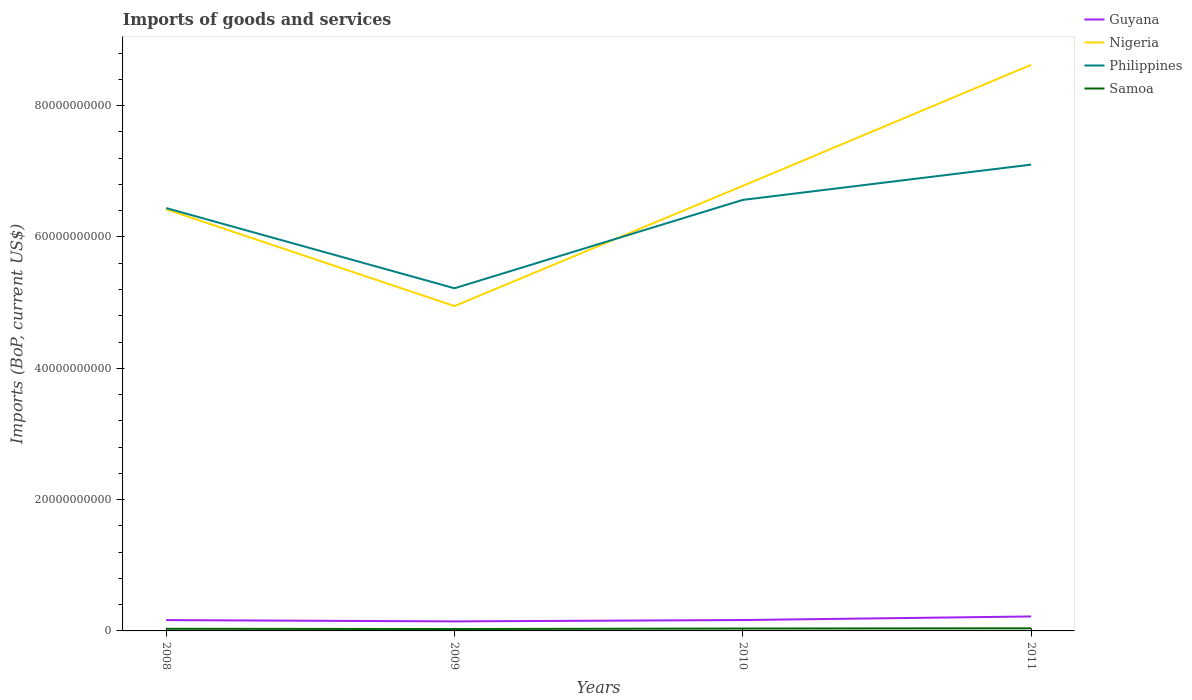Does the line corresponding to Guyana intersect with the line corresponding to Nigeria?
Provide a short and direct response. No. Across all years, what is the maximum amount spent on imports in Philippines?
Offer a terse response. 5.22e+1. What is the total amount spent on imports in Guyana in the graph?
Give a very brief answer. -5.47e+08. What is the difference between the highest and the second highest amount spent on imports in Samoa?
Keep it short and to the point. 1.09e+08. Are the values on the major ticks of Y-axis written in scientific E-notation?
Provide a succinct answer. No. Does the graph contain grids?
Give a very brief answer. No. Where does the legend appear in the graph?
Your response must be concise. Top right. What is the title of the graph?
Provide a succinct answer. Imports of goods and services. Does "Norway" appear as one of the legend labels in the graph?
Provide a short and direct response. No. What is the label or title of the Y-axis?
Offer a terse response. Imports (BoP, current US$). What is the Imports (BoP, current US$) in Guyana in 2008?
Provide a short and direct response. 1.65e+09. What is the Imports (BoP, current US$) of Nigeria in 2008?
Provide a short and direct response. 6.42e+1. What is the Imports (BoP, current US$) of Philippines in 2008?
Ensure brevity in your answer.  6.44e+1. What is the Imports (BoP, current US$) of Samoa in 2008?
Your answer should be very brief. 3.22e+08. What is the Imports (BoP, current US$) of Guyana in 2009?
Ensure brevity in your answer.  1.45e+09. What is the Imports (BoP, current US$) of Nigeria in 2009?
Keep it short and to the point. 4.95e+1. What is the Imports (BoP, current US$) of Philippines in 2009?
Your answer should be very brief. 5.22e+1. What is the Imports (BoP, current US$) in Samoa in 2009?
Ensure brevity in your answer.  2.87e+08. What is the Imports (BoP, current US$) in Guyana in 2010?
Provide a short and direct response. 1.66e+09. What is the Imports (BoP, current US$) in Nigeria in 2010?
Provide a succinct answer. 6.78e+1. What is the Imports (BoP, current US$) of Philippines in 2010?
Give a very brief answer. 6.56e+1. What is the Imports (BoP, current US$) of Samoa in 2010?
Make the answer very short. 3.62e+08. What is the Imports (BoP, current US$) of Guyana in 2011?
Provide a short and direct response. 2.20e+09. What is the Imports (BoP, current US$) in Nigeria in 2011?
Your response must be concise. 8.62e+1. What is the Imports (BoP, current US$) of Philippines in 2011?
Provide a short and direct response. 7.10e+1. What is the Imports (BoP, current US$) in Samoa in 2011?
Offer a very short reply. 3.97e+08. Across all years, what is the maximum Imports (BoP, current US$) of Guyana?
Your response must be concise. 2.20e+09. Across all years, what is the maximum Imports (BoP, current US$) in Nigeria?
Offer a very short reply. 8.62e+1. Across all years, what is the maximum Imports (BoP, current US$) in Philippines?
Your response must be concise. 7.10e+1. Across all years, what is the maximum Imports (BoP, current US$) of Samoa?
Ensure brevity in your answer.  3.97e+08. Across all years, what is the minimum Imports (BoP, current US$) in Guyana?
Your answer should be very brief. 1.45e+09. Across all years, what is the minimum Imports (BoP, current US$) in Nigeria?
Your answer should be very brief. 4.95e+1. Across all years, what is the minimum Imports (BoP, current US$) of Philippines?
Provide a short and direct response. 5.22e+1. Across all years, what is the minimum Imports (BoP, current US$) of Samoa?
Your answer should be very brief. 2.87e+08. What is the total Imports (BoP, current US$) in Guyana in the graph?
Keep it short and to the point. 6.96e+09. What is the total Imports (BoP, current US$) of Nigeria in the graph?
Keep it short and to the point. 2.68e+11. What is the total Imports (BoP, current US$) of Philippines in the graph?
Offer a very short reply. 2.53e+11. What is the total Imports (BoP, current US$) of Samoa in the graph?
Your response must be concise. 1.37e+09. What is the difference between the Imports (BoP, current US$) in Guyana in 2008 and that in 2009?
Your response must be concise. 1.97e+08. What is the difference between the Imports (BoP, current US$) of Nigeria in 2008 and that in 2009?
Ensure brevity in your answer.  1.47e+1. What is the difference between the Imports (BoP, current US$) of Philippines in 2008 and that in 2009?
Keep it short and to the point. 1.22e+1. What is the difference between the Imports (BoP, current US$) in Samoa in 2008 and that in 2009?
Provide a short and direct response. 3.50e+07. What is the difference between the Imports (BoP, current US$) of Guyana in 2008 and that in 2010?
Provide a short and direct response. -8.76e+06. What is the difference between the Imports (BoP, current US$) of Nigeria in 2008 and that in 2010?
Your answer should be very brief. -3.56e+09. What is the difference between the Imports (BoP, current US$) of Philippines in 2008 and that in 2010?
Offer a very short reply. -1.24e+09. What is the difference between the Imports (BoP, current US$) in Samoa in 2008 and that in 2010?
Give a very brief answer. -3.93e+07. What is the difference between the Imports (BoP, current US$) in Guyana in 2008 and that in 2011?
Your response must be concise. -5.55e+08. What is the difference between the Imports (BoP, current US$) in Nigeria in 2008 and that in 2011?
Your answer should be very brief. -2.20e+1. What is the difference between the Imports (BoP, current US$) of Philippines in 2008 and that in 2011?
Offer a terse response. -6.61e+09. What is the difference between the Imports (BoP, current US$) in Samoa in 2008 and that in 2011?
Offer a very short reply. -7.43e+07. What is the difference between the Imports (BoP, current US$) of Guyana in 2009 and that in 2010?
Provide a short and direct response. -2.06e+08. What is the difference between the Imports (BoP, current US$) in Nigeria in 2009 and that in 2010?
Your answer should be compact. -1.83e+1. What is the difference between the Imports (BoP, current US$) of Philippines in 2009 and that in 2010?
Your answer should be very brief. -1.35e+1. What is the difference between the Imports (BoP, current US$) in Samoa in 2009 and that in 2010?
Ensure brevity in your answer.  -7.43e+07. What is the difference between the Imports (BoP, current US$) of Guyana in 2009 and that in 2011?
Your answer should be compact. -7.52e+08. What is the difference between the Imports (BoP, current US$) of Nigeria in 2009 and that in 2011?
Your answer should be very brief. -3.68e+1. What is the difference between the Imports (BoP, current US$) in Philippines in 2009 and that in 2011?
Your response must be concise. -1.88e+1. What is the difference between the Imports (BoP, current US$) in Samoa in 2009 and that in 2011?
Keep it short and to the point. -1.09e+08. What is the difference between the Imports (BoP, current US$) in Guyana in 2010 and that in 2011?
Your answer should be compact. -5.47e+08. What is the difference between the Imports (BoP, current US$) in Nigeria in 2010 and that in 2011?
Your answer should be very brief. -1.84e+1. What is the difference between the Imports (BoP, current US$) in Philippines in 2010 and that in 2011?
Give a very brief answer. -5.37e+09. What is the difference between the Imports (BoP, current US$) of Samoa in 2010 and that in 2011?
Provide a succinct answer. -3.51e+07. What is the difference between the Imports (BoP, current US$) of Guyana in 2008 and the Imports (BoP, current US$) of Nigeria in 2009?
Provide a succinct answer. -4.78e+1. What is the difference between the Imports (BoP, current US$) in Guyana in 2008 and the Imports (BoP, current US$) in Philippines in 2009?
Your response must be concise. -5.05e+1. What is the difference between the Imports (BoP, current US$) in Guyana in 2008 and the Imports (BoP, current US$) in Samoa in 2009?
Give a very brief answer. 1.36e+09. What is the difference between the Imports (BoP, current US$) in Nigeria in 2008 and the Imports (BoP, current US$) in Philippines in 2009?
Your answer should be very brief. 1.20e+1. What is the difference between the Imports (BoP, current US$) of Nigeria in 2008 and the Imports (BoP, current US$) of Samoa in 2009?
Ensure brevity in your answer.  6.39e+1. What is the difference between the Imports (BoP, current US$) of Philippines in 2008 and the Imports (BoP, current US$) of Samoa in 2009?
Give a very brief answer. 6.41e+1. What is the difference between the Imports (BoP, current US$) of Guyana in 2008 and the Imports (BoP, current US$) of Nigeria in 2010?
Your answer should be compact. -6.61e+1. What is the difference between the Imports (BoP, current US$) of Guyana in 2008 and the Imports (BoP, current US$) of Philippines in 2010?
Your answer should be very brief. -6.40e+1. What is the difference between the Imports (BoP, current US$) in Guyana in 2008 and the Imports (BoP, current US$) in Samoa in 2010?
Offer a very short reply. 1.29e+09. What is the difference between the Imports (BoP, current US$) in Nigeria in 2008 and the Imports (BoP, current US$) in Philippines in 2010?
Ensure brevity in your answer.  -1.43e+09. What is the difference between the Imports (BoP, current US$) of Nigeria in 2008 and the Imports (BoP, current US$) of Samoa in 2010?
Give a very brief answer. 6.39e+1. What is the difference between the Imports (BoP, current US$) in Philippines in 2008 and the Imports (BoP, current US$) in Samoa in 2010?
Provide a short and direct response. 6.40e+1. What is the difference between the Imports (BoP, current US$) of Guyana in 2008 and the Imports (BoP, current US$) of Nigeria in 2011?
Provide a succinct answer. -8.46e+1. What is the difference between the Imports (BoP, current US$) in Guyana in 2008 and the Imports (BoP, current US$) in Philippines in 2011?
Provide a short and direct response. -6.94e+1. What is the difference between the Imports (BoP, current US$) in Guyana in 2008 and the Imports (BoP, current US$) in Samoa in 2011?
Your answer should be very brief. 1.25e+09. What is the difference between the Imports (BoP, current US$) in Nigeria in 2008 and the Imports (BoP, current US$) in Philippines in 2011?
Your response must be concise. -6.80e+09. What is the difference between the Imports (BoP, current US$) of Nigeria in 2008 and the Imports (BoP, current US$) of Samoa in 2011?
Keep it short and to the point. 6.38e+1. What is the difference between the Imports (BoP, current US$) of Philippines in 2008 and the Imports (BoP, current US$) of Samoa in 2011?
Ensure brevity in your answer.  6.40e+1. What is the difference between the Imports (BoP, current US$) of Guyana in 2009 and the Imports (BoP, current US$) of Nigeria in 2010?
Give a very brief answer. -6.63e+1. What is the difference between the Imports (BoP, current US$) of Guyana in 2009 and the Imports (BoP, current US$) of Philippines in 2010?
Provide a succinct answer. -6.42e+1. What is the difference between the Imports (BoP, current US$) of Guyana in 2009 and the Imports (BoP, current US$) of Samoa in 2010?
Give a very brief answer. 1.09e+09. What is the difference between the Imports (BoP, current US$) in Nigeria in 2009 and the Imports (BoP, current US$) in Philippines in 2010?
Make the answer very short. -1.62e+1. What is the difference between the Imports (BoP, current US$) in Nigeria in 2009 and the Imports (BoP, current US$) in Samoa in 2010?
Keep it short and to the point. 4.91e+1. What is the difference between the Imports (BoP, current US$) of Philippines in 2009 and the Imports (BoP, current US$) of Samoa in 2010?
Offer a very short reply. 5.18e+1. What is the difference between the Imports (BoP, current US$) in Guyana in 2009 and the Imports (BoP, current US$) in Nigeria in 2011?
Provide a succinct answer. -8.48e+1. What is the difference between the Imports (BoP, current US$) of Guyana in 2009 and the Imports (BoP, current US$) of Philippines in 2011?
Your answer should be compact. -6.96e+1. What is the difference between the Imports (BoP, current US$) in Guyana in 2009 and the Imports (BoP, current US$) in Samoa in 2011?
Make the answer very short. 1.06e+09. What is the difference between the Imports (BoP, current US$) in Nigeria in 2009 and the Imports (BoP, current US$) in Philippines in 2011?
Your answer should be very brief. -2.15e+1. What is the difference between the Imports (BoP, current US$) in Nigeria in 2009 and the Imports (BoP, current US$) in Samoa in 2011?
Your answer should be very brief. 4.91e+1. What is the difference between the Imports (BoP, current US$) of Philippines in 2009 and the Imports (BoP, current US$) of Samoa in 2011?
Provide a succinct answer. 5.18e+1. What is the difference between the Imports (BoP, current US$) in Guyana in 2010 and the Imports (BoP, current US$) in Nigeria in 2011?
Your answer should be very brief. -8.46e+1. What is the difference between the Imports (BoP, current US$) in Guyana in 2010 and the Imports (BoP, current US$) in Philippines in 2011?
Provide a succinct answer. -6.94e+1. What is the difference between the Imports (BoP, current US$) in Guyana in 2010 and the Imports (BoP, current US$) in Samoa in 2011?
Keep it short and to the point. 1.26e+09. What is the difference between the Imports (BoP, current US$) in Nigeria in 2010 and the Imports (BoP, current US$) in Philippines in 2011?
Offer a terse response. -3.24e+09. What is the difference between the Imports (BoP, current US$) in Nigeria in 2010 and the Imports (BoP, current US$) in Samoa in 2011?
Offer a terse response. 6.74e+1. What is the difference between the Imports (BoP, current US$) in Philippines in 2010 and the Imports (BoP, current US$) in Samoa in 2011?
Ensure brevity in your answer.  6.53e+1. What is the average Imports (BoP, current US$) in Guyana per year?
Provide a short and direct response. 1.74e+09. What is the average Imports (BoP, current US$) of Nigeria per year?
Your response must be concise. 6.69e+1. What is the average Imports (BoP, current US$) of Philippines per year?
Keep it short and to the point. 6.33e+1. What is the average Imports (BoP, current US$) of Samoa per year?
Your answer should be very brief. 3.42e+08. In the year 2008, what is the difference between the Imports (BoP, current US$) of Guyana and Imports (BoP, current US$) of Nigeria?
Keep it short and to the point. -6.26e+1. In the year 2008, what is the difference between the Imports (BoP, current US$) in Guyana and Imports (BoP, current US$) in Philippines?
Provide a succinct answer. -6.28e+1. In the year 2008, what is the difference between the Imports (BoP, current US$) of Guyana and Imports (BoP, current US$) of Samoa?
Provide a succinct answer. 1.33e+09. In the year 2008, what is the difference between the Imports (BoP, current US$) of Nigeria and Imports (BoP, current US$) of Philippines?
Your response must be concise. -1.88e+08. In the year 2008, what is the difference between the Imports (BoP, current US$) in Nigeria and Imports (BoP, current US$) in Samoa?
Provide a short and direct response. 6.39e+1. In the year 2008, what is the difference between the Imports (BoP, current US$) in Philippines and Imports (BoP, current US$) in Samoa?
Your answer should be compact. 6.41e+1. In the year 2009, what is the difference between the Imports (BoP, current US$) of Guyana and Imports (BoP, current US$) of Nigeria?
Ensure brevity in your answer.  -4.80e+1. In the year 2009, what is the difference between the Imports (BoP, current US$) of Guyana and Imports (BoP, current US$) of Philippines?
Give a very brief answer. -5.07e+1. In the year 2009, what is the difference between the Imports (BoP, current US$) in Guyana and Imports (BoP, current US$) in Samoa?
Offer a very short reply. 1.16e+09. In the year 2009, what is the difference between the Imports (BoP, current US$) in Nigeria and Imports (BoP, current US$) in Philippines?
Keep it short and to the point. -2.71e+09. In the year 2009, what is the difference between the Imports (BoP, current US$) of Nigeria and Imports (BoP, current US$) of Samoa?
Offer a terse response. 4.92e+1. In the year 2009, what is the difference between the Imports (BoP, current US$) in Philippines and Imports (BoP, current US$) in Samoa?
Keep it short and to the point. 5.19e+1. In the year 2010, what is the difference between the Imports (BoP, current US$) of Guyana and Imports (BoP, current US$) of Nigeria?
Provide a short and direct response. -6.61e+1. In the year 2010, what is the difference between the Imports (BoP, current US$) in Guyana and Imports (BoP, current US$) in Philippines?
Keep it short and to the point. -6.40e+1. In the year 2010, what is the difference between the Imports (BoP, current US$) in Guyana and Imports (BoP, current US$) in Samoa?
Ensure brevity in your answer.  1.30e+09. In the year 2010, what is the difference between the Imports (BoP, current US$) of Nigeria and Imports (BoP, current US$) of Philippines?
Ensure brevity in your answer.  2.14e+09. In the year 2010, what is the difference between the Imports (BoP, current US$) in Nigeria and Imports (BoP, current US$) in Samoa?
Your answer should be very brief. 6.74e+1. In the year 2010, what is the difference between the Imports (BoP, current US$) of Philippines and Imports (BoP, current US$) of Samoa?
Offer a terse response. 6.53e+1. In the year 2011, what is the difference between the Imports (BoP, current US$) in Guyana and Imports (BoP, current US$) in Nigeria?
Offer a terse response. -8.40e+1. In the year 2011, what is the difference between the Imports (BoP, current US$) of Guyana and Imports (BoP, current US$) of Philippines?
Your answer should be very brief. -6.88e+1. In the year 2011, what is the difference between the Imports (BoP, current US$) of Guyana and Imports (BoP, current US$) of Samoa?
Offer a very short reply. 1.81e+09. In the year 2011, what is the difference between the Imports (BoP, current US$) in Nigeria and Imports (BoP, current US$) in Philippines?
Offer a terse response. 1.52e+1. In the year 2011, what is the difference between the Imports (BoP, current US$) in Nigeria and Imports (BoP, current US$) in Samoa?
Keep it short and to the point. 8.58e+1. In the year 2011, what is the difference between the Imports (BoP, current US$) in Philippines and Imports (BoP, current US$) in Samoa?
Provide a succinct answer. 7.06e+1. What is the ratio of the Imports (BoP, current US$) in Guyana in 2008 to that in 2009?
Make the answer very short. 1.14. What is the ratio of the Imports (BoP, current US$) in Nigeria in 2008 to that in 2009?
Provide a succinct answer. 1.3. What is the ratio of the Imports (BoP, current US$) of Philippines in 2008 to that in 2009?
Your answer should be very brief. 1.23. What is the ratio of the Imports (BoP, current US$) in Samoa in 2008 to that in 2009?
Provide a short and direct response. 1.12. What is the ratio of the Imports (BoP, current US$) of Guyana in 2008 to that in 2010?
Provide a succinct answer. 0.99. What is the ratio of the Imports (BoP, current US$) in Nigeria in 2008 to that in 2010?
Make the answer very short. 0.95. What is the ratio of the Imports (BoP, current US$) in Philippines in 2008 to that in 2010?
Your answer should be very brief. 0.98. What is the ratio of the Imports (BoP, current US$) of Samoa in 2008 to that in 2010?
Offer a terse response. 0.89. What is the ratio of the Imports (BoP, current US$) of Guyana in 2008 to that in 2011?
Make the answer very short. 0.75. What is the ratio of the Imports (BoP, current US$) in Nigeria in 2008 to that in 2011?
Your answer should be very brief. 0.74. What is the ratio of the Imports (BoP, current US$) of Philippines in 2008 to that in 2011?
Offer a very short reply. 0.91. What is the ratio of the Imports (BoP, current US$) in Samoa in 2008 to that in 2011?
Keep it short and to the point. 0.81. What is the ratio of the Imports (BoP, current US$) of Guyana in 2009 to that in 2010?
Make the answer very short. 0.88. What is the ratio of the Imports (BoP, current US$) of Nigeria in 2009 to that in 2010?
Make the answer very short. 0.73. What is the ratio of the Imports (BoP, current US$) in Philippines in 2009 to that in 2010?
Your response must be concise. 0.8. What is the ratio of the Imports (BoP, current US$) of Samoa in 2009 to that in 2010?
Your answer should be compact. 0.79. What is the ratio of the Imports (BoP, current US$) in Guyana in 2009 to that in 2011?
Offer a terse response. 0.66. What is the ratio of the Imports (BoP, current US$) in Nigeria in 2009 to that in 2011?
Your answer should be compact. 0.57. What is the ratio of the Imports (BoP, current US$) in Philippines in 2009 to that in 2011?
Make the answer very short. 0.73. What is the ratio of the Imports (BoP, current US$) of Samoa in 2009 to that in 2011?
Offer a very short reply. 0.72. What is the ratio of the Imports (BoP, current US$) of Guyana in 2010 to that in 2011?
Provide a short and direct response. 0.75. What is the ratio of the Imports (BoP, current US$) of Nigeria in 2010 to that in 2011?
Provide a succinct answer. 0.79. What is the ratio of the Imports (BoP, current US$) in Philippines in 2010 to that in 2011?
Provide a short and direct response. 0.92. What is the ratio of the Imports (BoP, current US$) of Samoa in 2010 to that in 2011?
Give a very brief answer. 0.91. What is the difference between the highest and the second highest Imports (BoP, current US$) of Guyana?
Provide a short and direct response. 5.47e+08. What is the difference between the highest and the second highest Imports (BoP, current US$) in Nigeria?
Your response must be concise. 1.84e+1. What is the difference between the highest and the second highest Imports (BoP, current US$) of Philippines?
Provide a succinct answer. 5.37e+09. What is the difference between the highest and the second highest Imports (BoP, current US$) in Samoa?
Give a very brief answer. 3.51e+07. What is the difference between the highest and the lowest Imports (BoP, current US$) of Guyana?
Give a very brief answer. 7.52e+08. What is the difference between the highest and the lowest Imports (BoP, current US$) in Nigeria?
Give a very brief answer. 3.68e+1. What is the difference between the highest and the lowest Imports (BoP, current US$) of Philippines?
Provide a short and direct response. 1.88e+1. What is the difference between the highest and the lowest Imports (BoP, current US$) of Samoa?
Your answer should be very brief. 1.09e+08. 